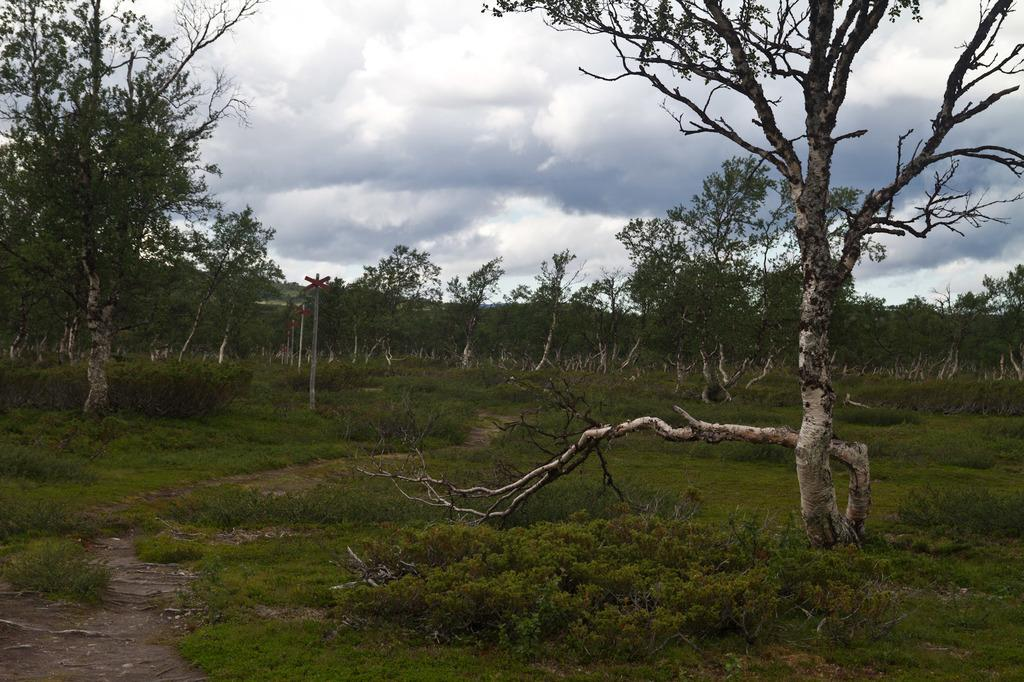What type of vegetation can be seen in the image? There are trees, plants, and grass in the image. What part of the natural environment is visible in the image? The sky is visible in the background of the image. What type of suit is hanging on the tree in the image? There is no suit present in the image; it features trees, plants, grass, and the sky. What type of pot can be seen rolling across the grass in the image? There is no pot present in the image, and nothing is rolling across the grass. 